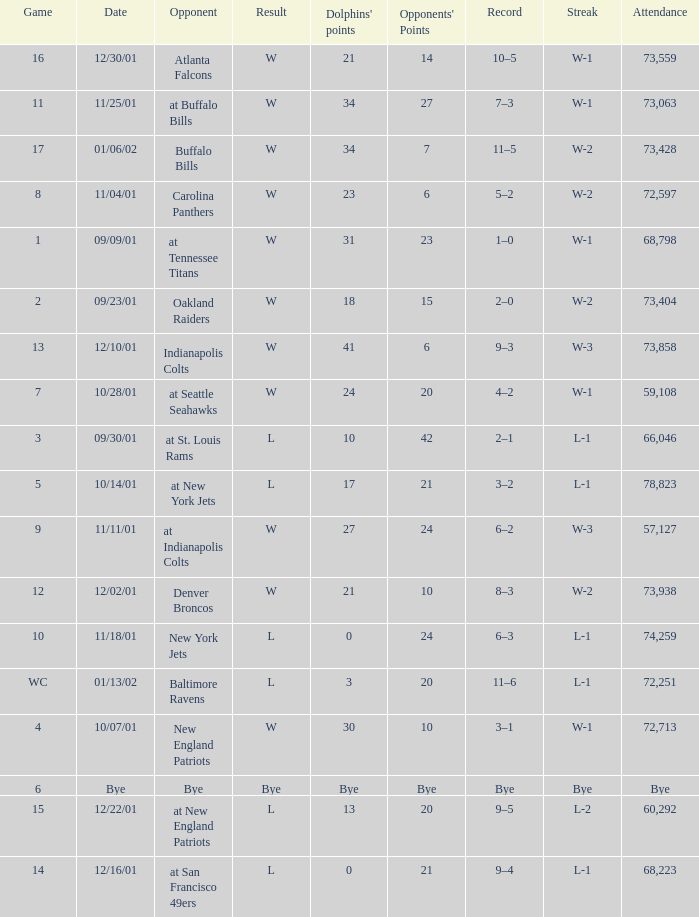What was the attendance of the Oakland Raiders game? 73404.0. 